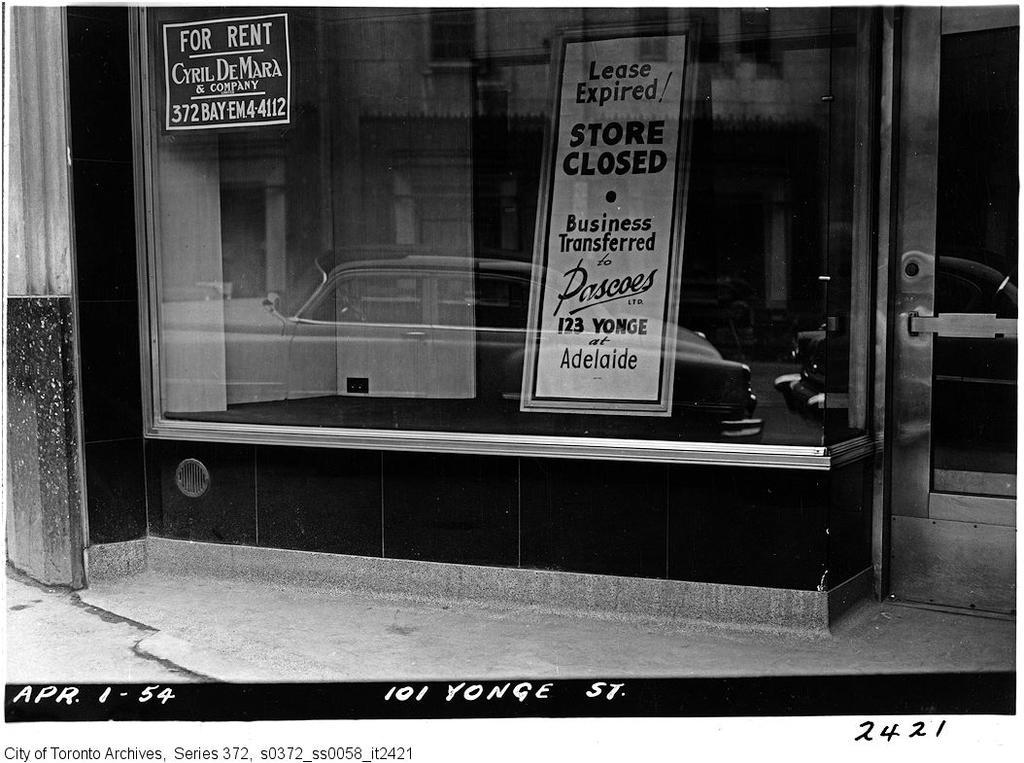Describe this image in one or two sentences. This image consists of a shop or a restaurant. In the front, we can see the boards. On the right, there is a door. At the bottom, there is a road. 